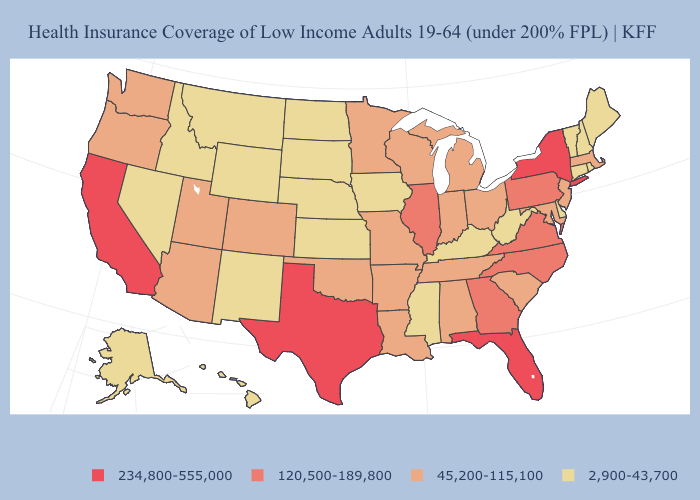Does Utah have the lowest value in the West?
Keep it brief. No. Does the first symbol in the legend represent the smallest category?
Short answer required. No. Does the first symbol in the legend represent the smallest category?
Answer briefly. No. Among the states that border Mississippi , which have the lowest value?
Be succinct. Alabama, Arkansas, Louisiana, Tennessee. Does Louisiana have the same value as Wyoming?
Be succinct. No. What is the value of Iowa?
Concise answer only. 2,900-43,700. Is the legend a continuous bar?
Concise answer only. No. What is the lowest value in the USA?
Keep it brief. 2,900-43,700. Does Indiana have a higher value than Arizona?
Short answer required. No. What is the highest value in the Northeast ?
Keep it brief. 234,800-555,000. Name the states that have a value in the range 2,900-43,700?
Be succinct. Alaska, Connecticut, Delaware, Hawaii, Idaho, Iowa, Kansas, Kentucky, Maine, Mississippi, Montana, Nebraska, Nevada, New Hampshire, New Mexico, North Dakota, Rhode Island, South Dakota, Vermont, West Virginia, Wyoming. What is the lowest value in states that border Delaware?
Quick response, please. 45,200-115,100. Name the states that have a value in the range 2,900-43,700?
Give a very brief answer. Alaska, Connecticut, Delaware, Hawaii, Idaho, Iowa, Kansas, Kentucky, Maine, Mississippi, Montana, Nebraska, Nevada, New Hampshire, New Mexico, North Dakota, Rhode Island, South Dakota, Vermont, West Virginia, Wyoming. What is the lowest value in states that border Arkansas?
Give a very brief answer. 2,900-43,700. Among the states that border Iowa , which have the lowest value?
Answer briefly. Nebraska, South Dakota. 